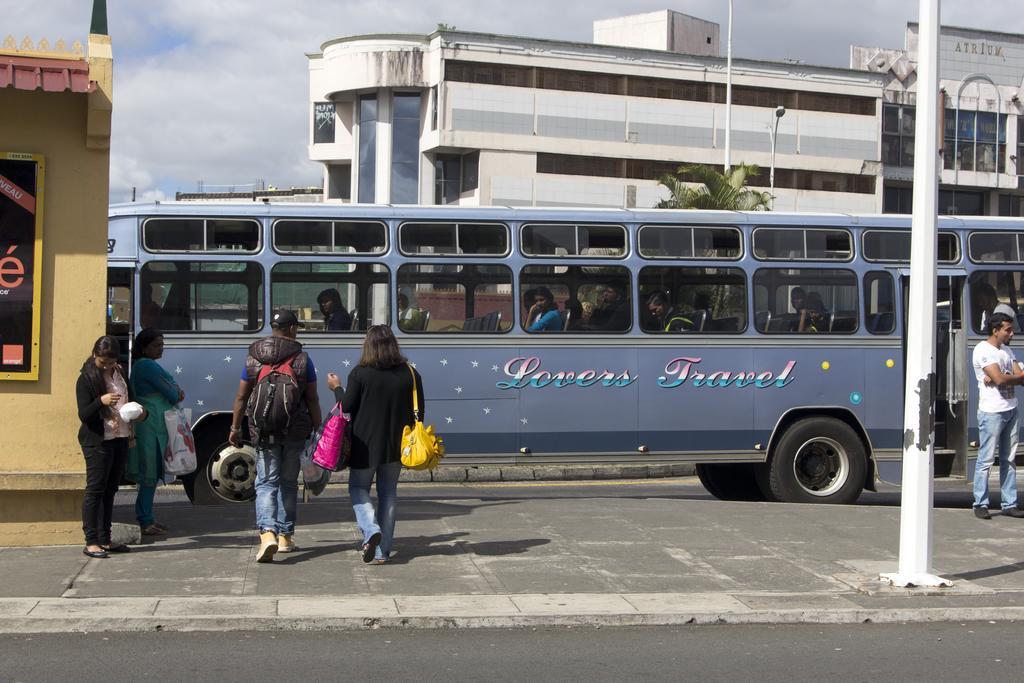Can you describe this image briefly? In this image, there are a few people. Among them, we can see some people in a vehicle. We can see the ground. There are a few buildings and poles with lights. We can also see a board with some text on one of the buildings on the left. We can see a tree and the sky with clouds. 